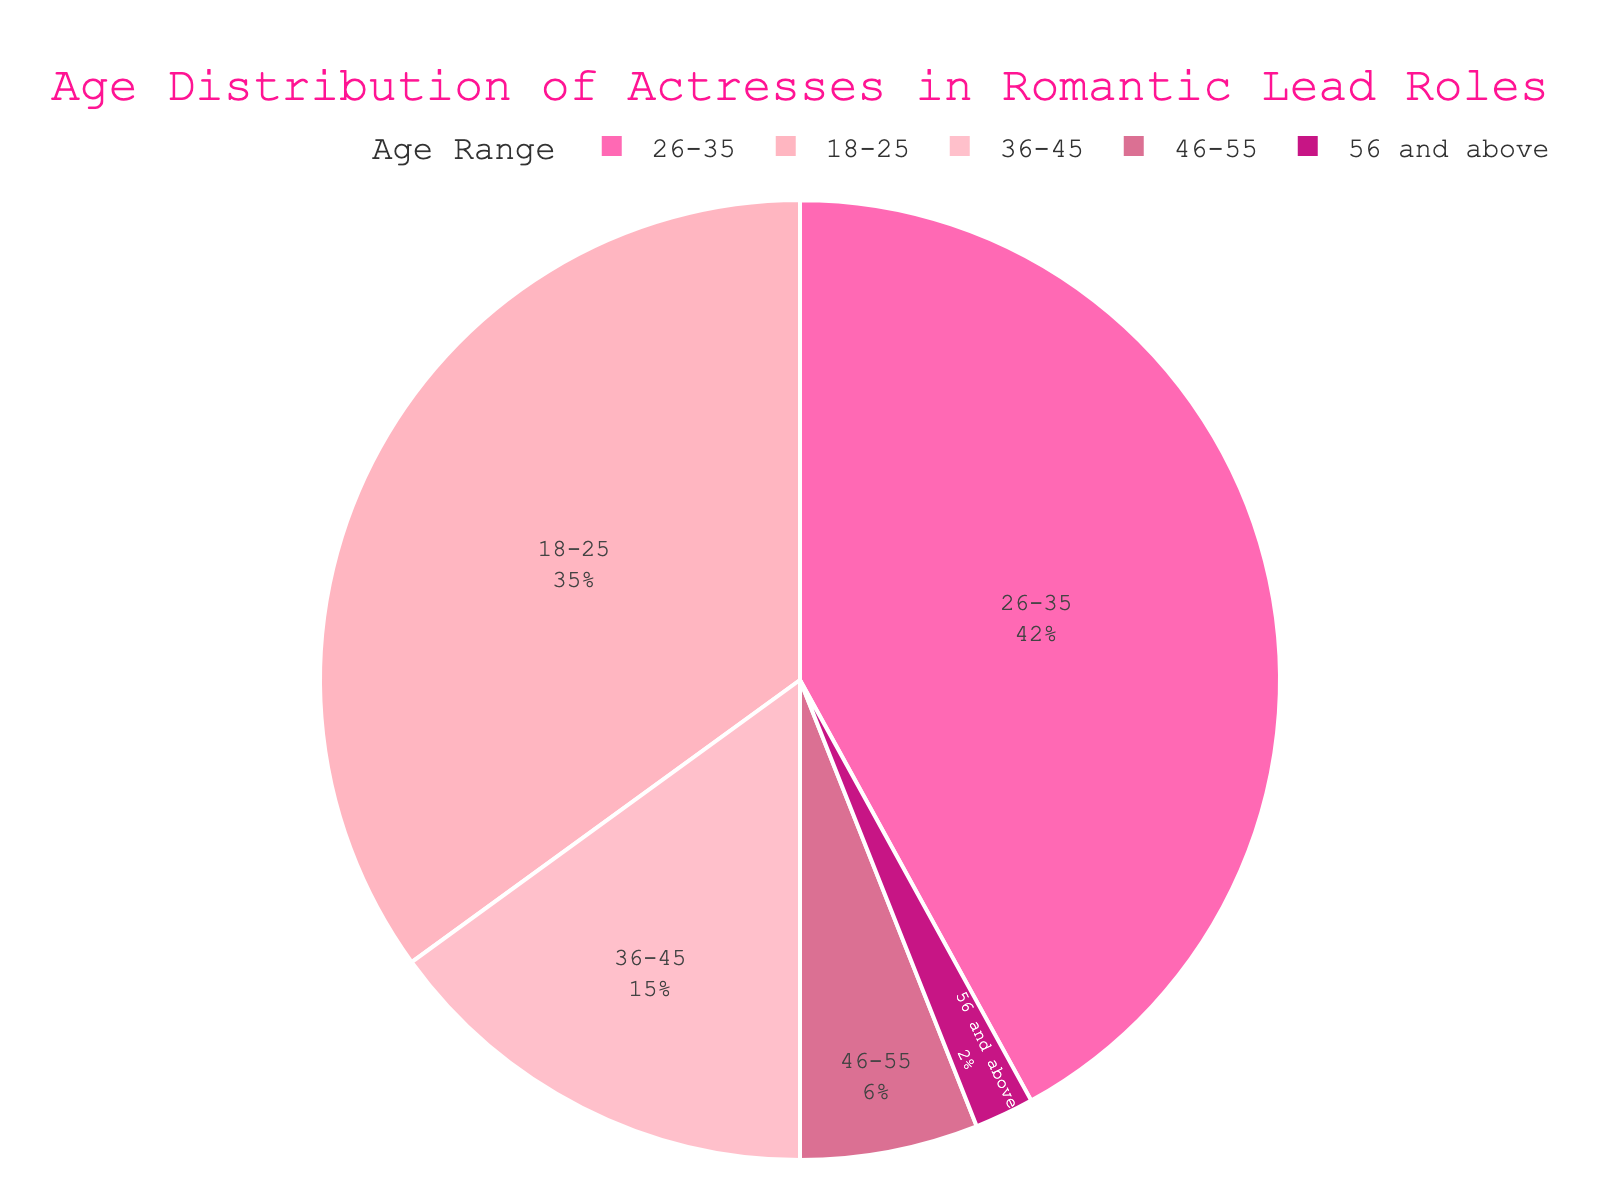Which age range has the highest percentage of actresses cast in romantic lead roles? The pie chart shows different age ranges with their corresponding percentages. The largest segment represents the age range with the highest percentage.
Answer: 26-35 Which age range has the lowest representation among actresses cast in romantic lead roles? To determine the lowest representation, look for the smallest segment in the pie chart.
Answer: 56 and above How do the combined percentages of actresses aged 18-25 and 26-35 compare to actresses aged 36-45? Sum the percentages of the 18-25 and 26-35 groups (35% + 42%) and compare it to the percentage of the 36-45 group. 77% (18-35) is much higher than 15% (36-45).
Answer: Combined percentage of 18-25 and 26-35 is higher What is the total percentage of actresses aged above 35 cast in romantic lead roles? Add the percentages of the age ranges 36-45, 46-55, and 56 and above: 15% + 6% + 2% = 23%.
Answer: 23% Which color represents the age range 36-45? Visually look for the segment labeled 36-45 and note its color.
Answer: Pink By how much does the percentage of actresses aged 46-55 differ from those aged 18-25? Subtract the percentage of the 46-55 group from that of the 18-25 group: 35% - 6% = 29%.
Answer: 29% How does the percentage of actresses aged 26-35 compare to the cumulative percentage of actresses aged 46-55 and 56 and above? Compare 42% (26-35) to the sum of 6% (46-55) and 2% (56 and above), which equals 8%. 42% is significantly higher than 8%.
Answer: Percentage of 26-35 is higher What percentage of actresses cast in romantic lead roles are under the age of 36? To find the percentage of actresses under 36, sum the percentages of the age ranges 18-25 and 26-35: 35% + 42% = 77%.
Answer: 77% Identify the two smallest age ranges in terms of percentage of actresses cast in romantic lead roles. The smallest segments are the ones with the least percentage leading up to the second lowest. These are 56 and above (2%) and 46-55 (6%).
Answer: 56 and above, 46-55 